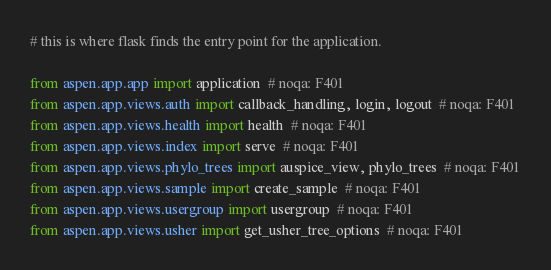<code> <loc_0><loc_0><loc_500><loc_500><_Python_># this is where flask finds the entry point for the application.

from aspen.app.app import application  # noqa: F401
from aspen.app.views.auth import callback_handling, login, logout  # noqa: F401
from aspen.app.views.health import health  # noqa: F401
from aspen.app.views.index import serve  # noqa: F401
from aspen.app.views.phylo_trees import auspice_view, phylo_trees  # noqa: F401
from aspen.app.views.sample import create_sample  # noqa: F401
from aspen.app.views.usergroup import usergroup  # noqa: F401
from aspen.app.views.usher import get_usher_tree_options  # noqa: F401
</code> 